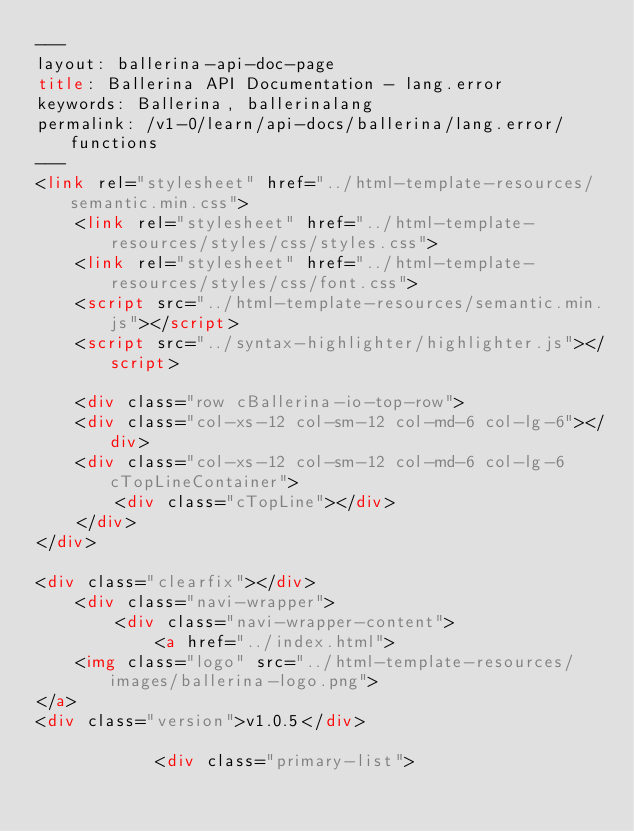Convert code to text. <code><loc_0><loc_0><loc_500><loc_500><_HTML_>---
layout: ballerina-api-doc-page
title: Ballerina API Documentation - lang.error
keywords: Ballerina, ballerinalang
permalink: /v1-0/learn/api-docs/ballerina/lang.error/functions
---
<link rel="stylesheet" href="../html-template-resources/semantic.min.css">
    <link rel="stylesheet" href="../html-template-resources/styles/css/styles.css">
    <link rel="stylesheet" href="../html-template-resources/styles/css/font.css">
    <script src="../html-template-resources/semantic.min.js"></script>
    <script src="../syntax-highlighter/highlighter.js"></script>
    
    <div class="row cBallerina-io-top-row">
    <div class="col-xs-12 col-sm-12 col-md-6 col-lg-6"></div>
    <div class="col-xs-12 col-sm-12 col-md-6 col-lg-6 cTopLineContainer">
        <div class="cTopLine"></div>
    </div>
</div>

<div class="clearfix"></div>
    <div class="navi-wrapper">
        <div class="navi-wrapper-content">
            <a href="../index.html">
    <img class="logo" src="../html-template-resources/images/ballerina-logo.png">
</a>
<div class="version">v1.0.5</div>

            <div class="primary-list"></code> 